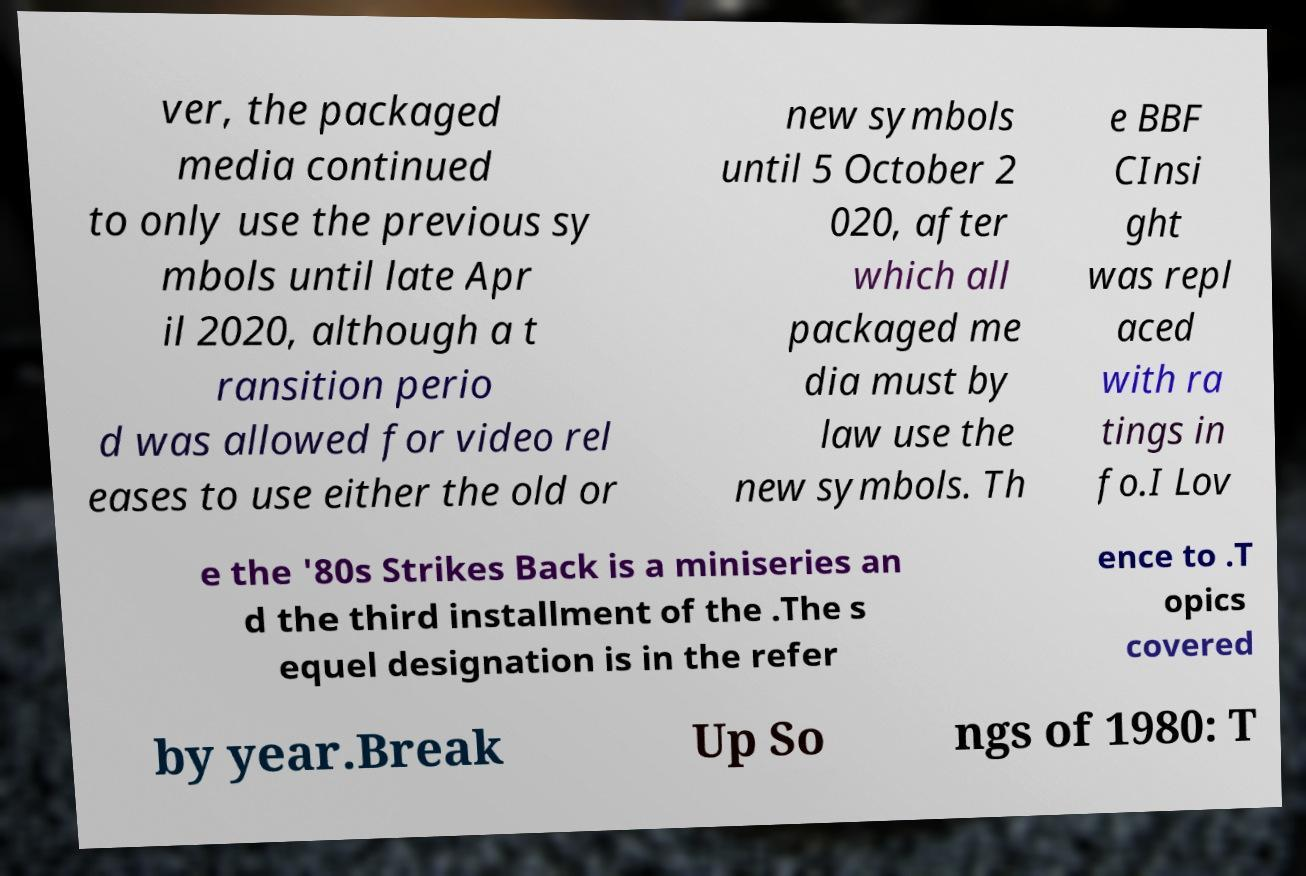Could you extract and type out the text from this image? ver, the packaged media continued to only use the previous sy mbols until late Apr il 2020, although a t ransition perio d was allowed for video rel eases to use either the old or new symbols until 5 October 2 020, after which all packaged me dia must by law use the new symbols. Th e BBF CInsi ght was repl aced with ra tings in fo.I Lov e the '80s Strikes Back is a miniseries an d the third installment of the .The s equel designation is in the refer ence to .T opics covered by year.Break Up So ngs of 1980: T 